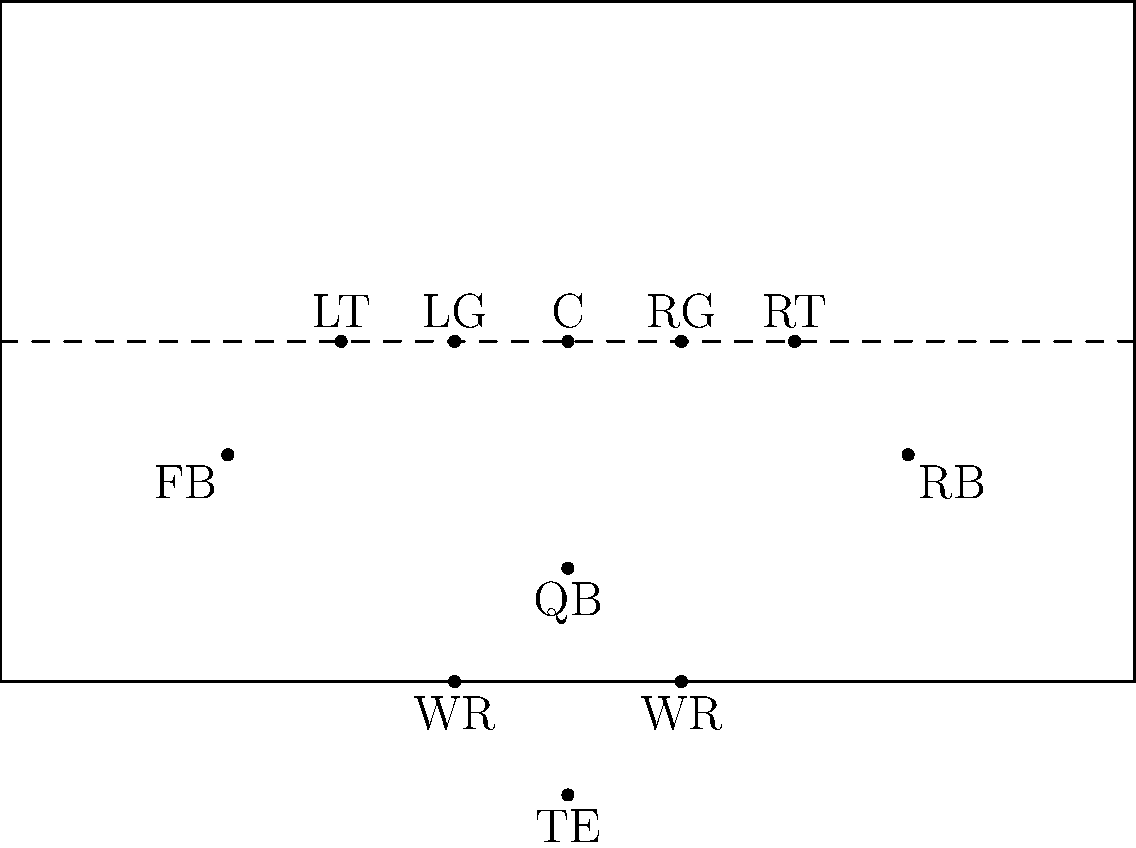Based on the aerial diagram of an offensive formation, which type of formation is this most likely representing? To identify this formation, let's analyze the positions step-by-step:

1. The offensive line is in a standard configuration with 5 players: LT, LG, C, RG, RT.
2. There is a QB directly behind the center, about 2 yards deep.
3. There are two running backs in the backfield, one on each side of the QB, slightly deeper and wider.
4. There are two wide receivers, one on each side, lined up near the sidelines.
5. There is an additional player lined up behind the wide receivers, likely a tight end.

This formation has the following key characteristics:
- A balanced line (5 linemen)
- A fullback and halfback in the backfield
- Two wide receivers
- One tight end

These elements are typical of the "I-Formation," a classic power running formation in football. The name comes from the alignment of the fullback, halfback, and quarterback, which forms an "I" shape when viewed from the side.

The I-Formation is known for its versatility, allowing for both strong running plays and play-action passes. It was a staple in many high school and college offenses, especially during the era when Art Haege would have been coaching.
Answer: I-Formation 